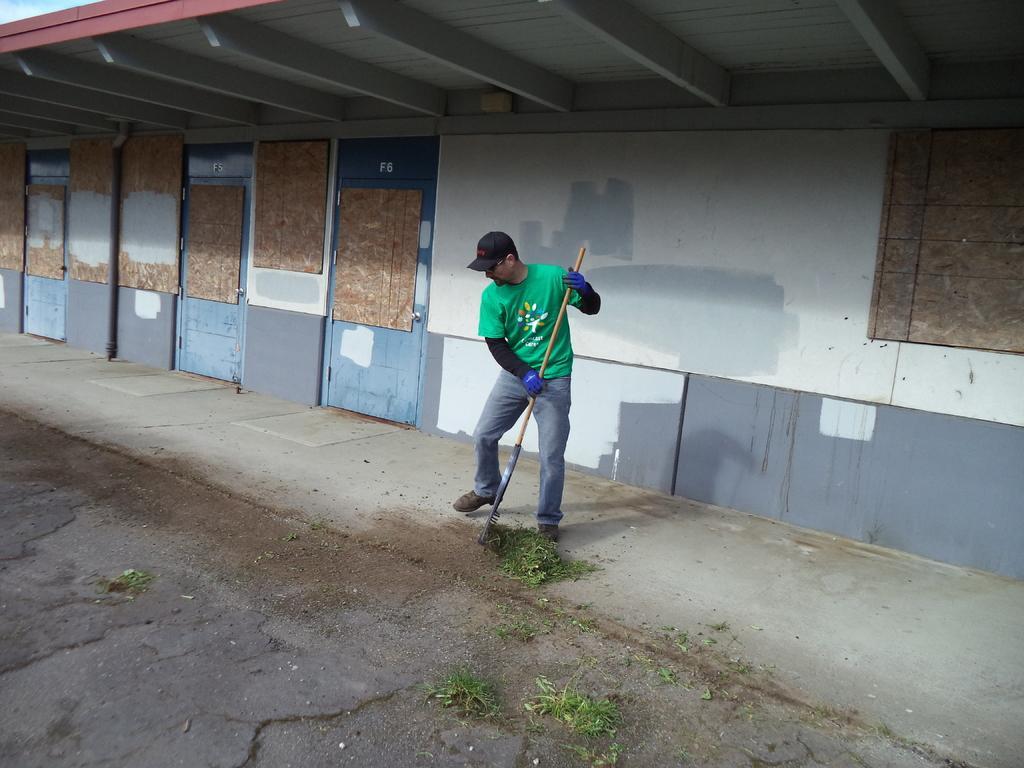Can you describe this image briefly? In the picture we can see a building wall with three doors in front of it we can see a man standing and cleaning the path with a stick and he is in green T-shirt, gloves and cap. 